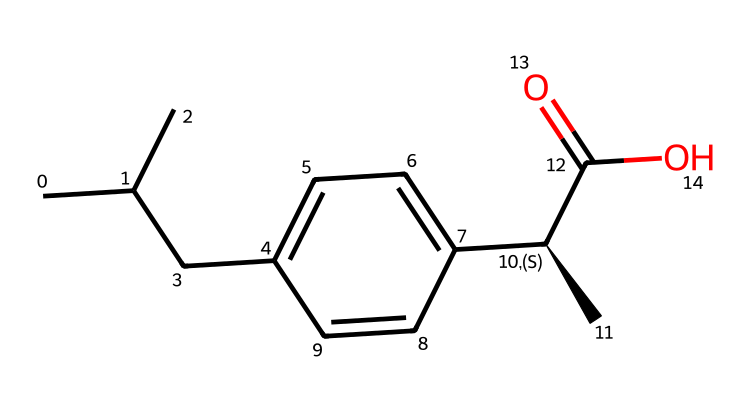What is the molecular formula of ibuprofen? By analyzing the SMILES representation, we can deduce the molecular formula by identifying the number of each type of atom present. We can count 13 carbon atoms (C), 18 hydrogen atoms (H), and 2 oxygen atoms (O), leading to the formula C13H18O2.
Answer: C13H18O2 How many rings are present in the structure of ibuprofen? The SMILES representation indicates there are no cyclic structures, as it does not contain any ring notation (such as numbers to denote bonds forming a ring). Therefore, we conclude that there are 0 rings.
Answer: 0 What type of functional group is present in ibuprofen? Identifying functional groups from the SMILES structure, we note the presence of a carboxylic acid group (C(=O)O), which is characterized by the carbonyl (C=O) and hydroxyl (-OH) groups attached to the same carbon atom.
Answer: carboxylic acid Is ibuprofen an acid or a base? The presence of the carboxylic acid functional group indicates that ibuprofen can dissociate into protons in solution, which classifies it as an acid, specifically a weak acid due to its pKa value being above 7.
Answer: acid How many stereocenters are in ibuprofen? The SMILES notation includes a "[@H]" symbol indicating chirality at one of the carbon atoms, which points to a stereocenter. Evaluating the structure, we identify only one stereocenter present at the indicated carbon.
Answer: 1 What is the total number of hydrogen atoms in ibuprofen? Counting from the molecular formula C13H18O2 derived from the SMILES representation, we specifically see there are a total of 18 hydrogen atoms in the structure.
Answer: 18 